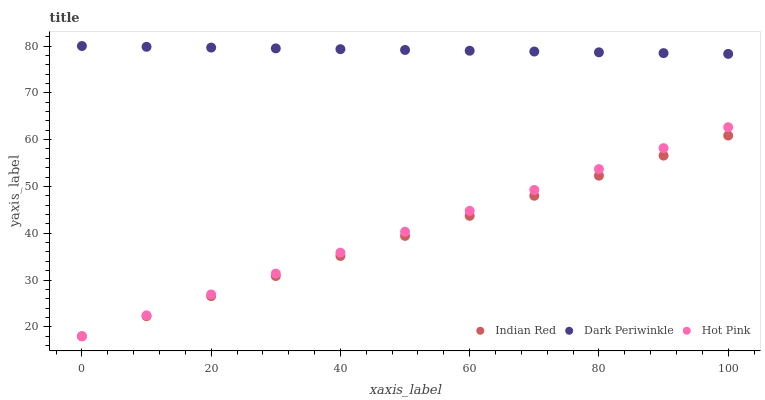Does Indian Red have the minimum area under the curve?
Answer yes or no. Yes. Does Dark Periwinkle have the maximum area under the curve?
Answer yes or no. Yes. Does Dark Periwinkle have the minimum area under the curve?
Answer yes or no. No. Does Indian Red have the maximum area under the curve?
Answer yes or no. No. Is Indian Red the smoothest?
Answer yes or no. Yes. Is Dark Periwinkle the roughest?
Answer yes or no. Yes. Is Dark Periwinkle the smoothest?
Answer yes or no. No. Is Indian Red the roughest?
Answer yes or no. No. Does Hot Pink have the lowest value?
Answer yes or no. Yes. Does Dark Periwinkle have the lowest value?
Answer yes or no. No. Does Dark Periwinkle have the highest value?
Answer yes or no. Yes. Does Indian Red have the highest value?
Answer yes or no. No. Is Indian Red less than Dark Periwinkle?
Answer yes or no. Yes. Is Dark Periwinkle greater than Hot Pink?
Answer yes or no. Yes. Does Indian Red intersect Hot Pink?
Answer yes or no. Yes. Is Indian Red less than Hot Pink?
Answer yes or no. No. Is Indian Red greater than Hot Pink?
Answer yes or no. No. Does Indian Red intersect Dark Periwinkle?
Answer yes or no. No. 